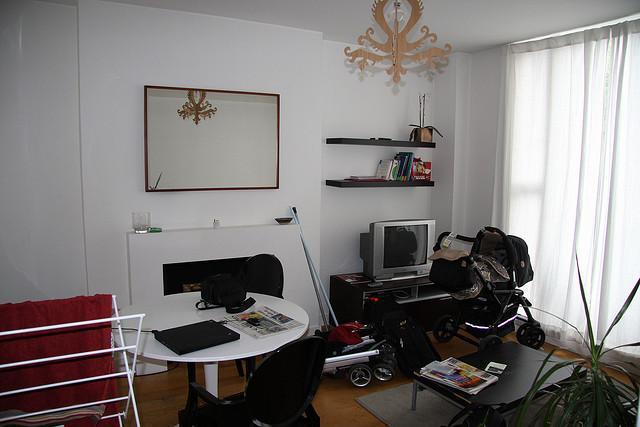Which object in the room is the most mobile?
Choose the right answer and clarify with the format: 'Answer: answer
Rationale: rationale.'
Options: Baby carriage, table, mirror, television. Answer: baby carriage.
Rationale: It has wheels and can be pushed. 